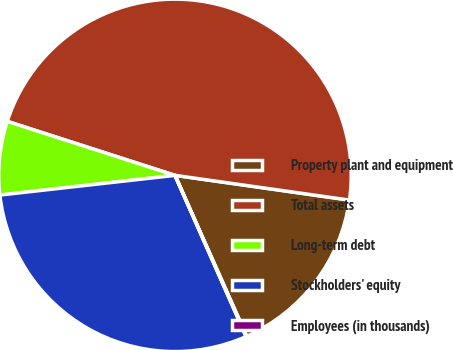Convert chart. <chart><loc_0><loc_0><loc_500><loc_500><pie_chart><fcel>Property plant and equipment<fcel>Total assets<fcel>Long-term debt<fcel>Stockholders' equity<fcel>Employees (in thousands)<nl><fcel>16.09%<fcel>47.29%<fcel>6.74%<fcel>29.83%<fcel>0.06%<nl></chart> 